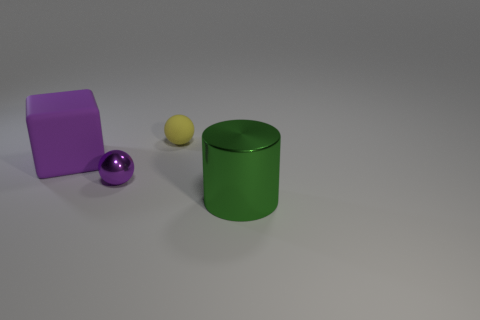Add 2 tiny red matte things. How many objects exist? 6 Subtract all cubes. How many objects are left? 3 Subtract all purple balls. How many balls are left? 1 Subtract 1 balls. How many balls are left? 1 Subtract all tiny green matte spheres. Subtract all small rubber things. How many objects are left? 3 Add 4 small purple metal spheres. How many small purple metal spheres are left? 5 Add 2 small purple shiny cylinders. How many small purple shiny cylinders exist? 2 Subtract 0 gray cylinders. How many objects are left? 4 Subtract all blue blocks. Subtract all brown balls. How many blocks are left? 1 Subtract all gray balls. How many green cubes are left? 0 